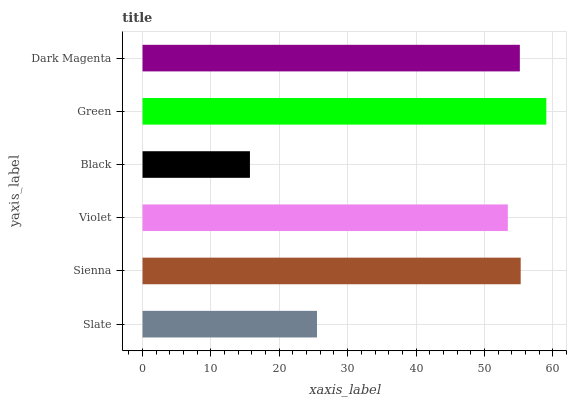Is Black the minimum?
Answer yes or no. Yes. Is Green the maximum?
Answer yes or no. Yes. Is Sienna the minimum?
Answer yes or no. No. Is Sienna the maximum?
Answer yes or no. No. Is Sienna greater than Slate?
Answer yes or no. Yes. Is Slate less than Sienna?
Answer yes or no. Yes. Is Slate greater than Sienna?
Answer yes or no. No. Is Sienna less than Slate?
Answer yes or no. No. Is Dark Magenta the high median?
Answer yes or no. Yes. Is Violet the low median?
Answer yes or no. Yes. Is Violet the high median?
Answer yes or no. No. Is Slate the low median?
Answer yes or no. No. 